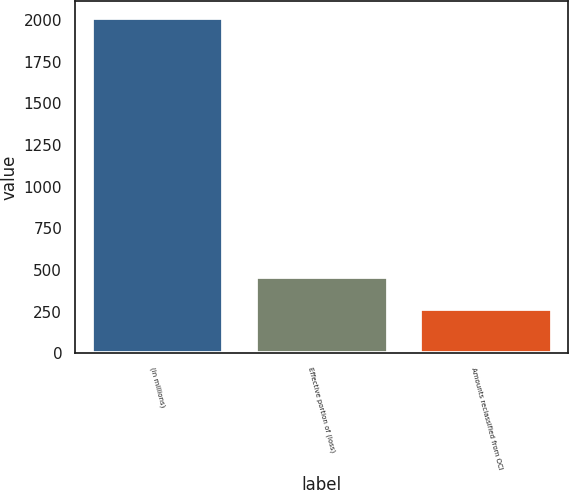Convert chart. <chart><loc_0><loc_0><loc_500><loc_500><bar_chart><fcel>(in millions)<fcel>Effective portion of (loss)<fcel>Amounts reclassified from OCI<nl><fcel>2014<fcel>460.4<fcel>266.2<nl></chart> 